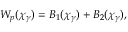<formula> <loc_0><loc_0><loc_500><loc_500>W _ { p } ( \chi _ { \gamma } ) = B _ { 1 } ( \chi _ { \gamma } ) + B _ { 2 } ( \chi _ { \gamma } ) ,</formula> 